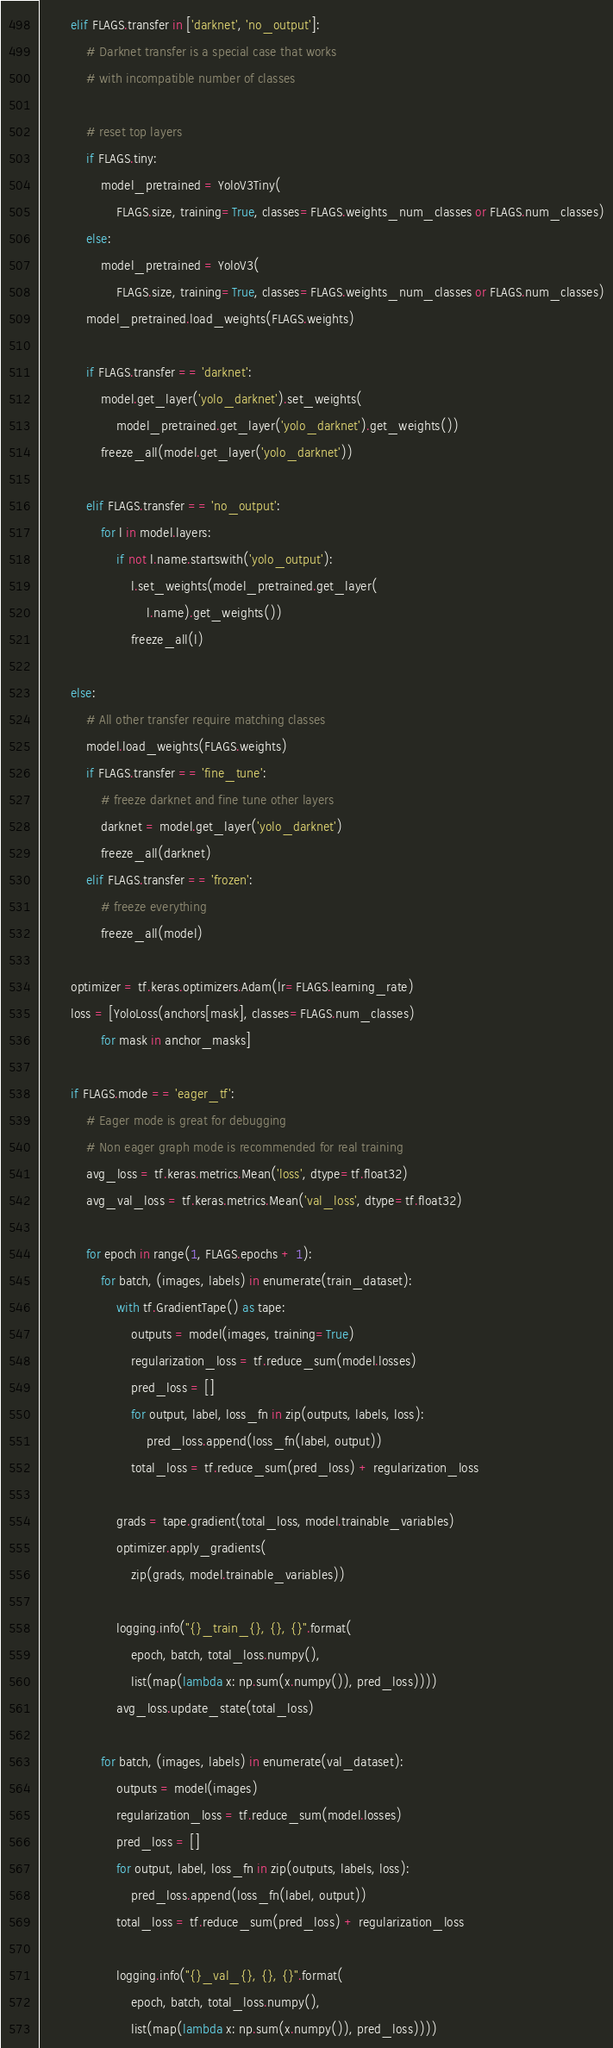<code> <loc_0><loc_0><loc_500><loc_500><_Python_>        elif FLAGS.transfer in ['darknet', 'no_output']:
            # Darknet transfer is a special case that works
            # with incompatible number of classes

            # reset top layers
            if FLAGS.tiny:
                model_pretrained = YoloV3Tiny(
                    FLAGS.size, training=True, classes=FLAGS.weights_num_classes or FLAGS.num_classes)
            else:
                model_pretrained = YoloV3(
                    FLAGS.size, training=True, classes=FLAGS.weights_num_classes or FLAGS.num_classes)
            model_pretrained.load_weights(FLAGS.weights)

            if FLAGS.transfer == 'darknet':
                model.get_layer('yolo_darknet').set_weights(
                    model_pretrained.get_layer('yolo_darknet').get_weights())
                freeze_all(model.get_layer('yolo_darknet'))

            elif FLAGS.transfer == 'no_output':
                for l in model.layers:
                    if not l.name.startswith('yolo_output'):
                        l.set_weights(model_pretrained.get_layer(
                            l.name).get_weights())
                        freeze_all(l)

        else:
            # All other transfer require matching classes
            model.load_weights(FLAGS.weights)
            if FLAGS.transfer == 'fine_tune':
                # freeze darknet and fine tune other layers
                darknet = model.get_layer('yolo_darknet')
                freeze_all(darknet)
            elif FLAGS.transfer == 'frozen':
                # freeze everything
                freeze_all(model)

        optimizer = tf.keras.optimizers.Adam(lr=FLAGS.learning_rate)
        loss = [YoloLoss(anchors[mask], classes=FLAGS.num_classes)
                for mask in anchor_masks]

        if FLAGS.mode == 'eager_tf':
            # Eager mode is great for debugging
            # Non eager graph mode is recommended for real training
            avg_loss = tf.keras.metrics.Mean('loss', dtype=tf.float32)
            avg_val_loss = tf.keras.metrics.Mean('val_loss', dtype=tf.float32)

            for epoch in range(1, FLAGS.epochs + 1):
                for batch, (images, labels) in enumerate(train_dataset):
                    with tf.GradientTape() as tape:
                        outputs = model(images, training=True)
                        regularization_loss = tf.reduce_sum(model.losses)
                        pred_loss = []
                        for output, label, loss_fn in zip(outputs, labels, loss):
                            pred_loss.append(loss_fn(label, output))
                        total_loss = tf.reduce_sum(pred_loss) + regularization_loss

                    grads = tape.gradient(total_loss, model.trainable_variables)
                    optimizer.apply_gradients(
                        zip(grads, model.trainable_variables))

                    logging.info("{}_train_{}, {}, {}".format(
                        epoch, batch, total_loss.numpy(),
                        list(map(lambda x: np.sum(x.numpy()), pred_loss))))
                    avg_loss.update_state(total_loss)

                for batch, (images, labels) in enumerate(val_dataset):
                    outputs = model(images)
                    regularization_loss = tf.reduce_sum(model.losses)
                    pred_loss = []
                    for output, label, loss_fn in zip(outputs, labels, loss):
                        pred_loss.append(loss_fn(label, output))
                    total_loss = tf.reduce_sum(pred_loss) + regularization_loss

                    logging.info("{}_val_{}, {}, {}".format(
                        epoch, batch, total_loss.numpy(),
                        list(map(lambda x: np.sum(x.numpy()), pred_loss))))</code> 